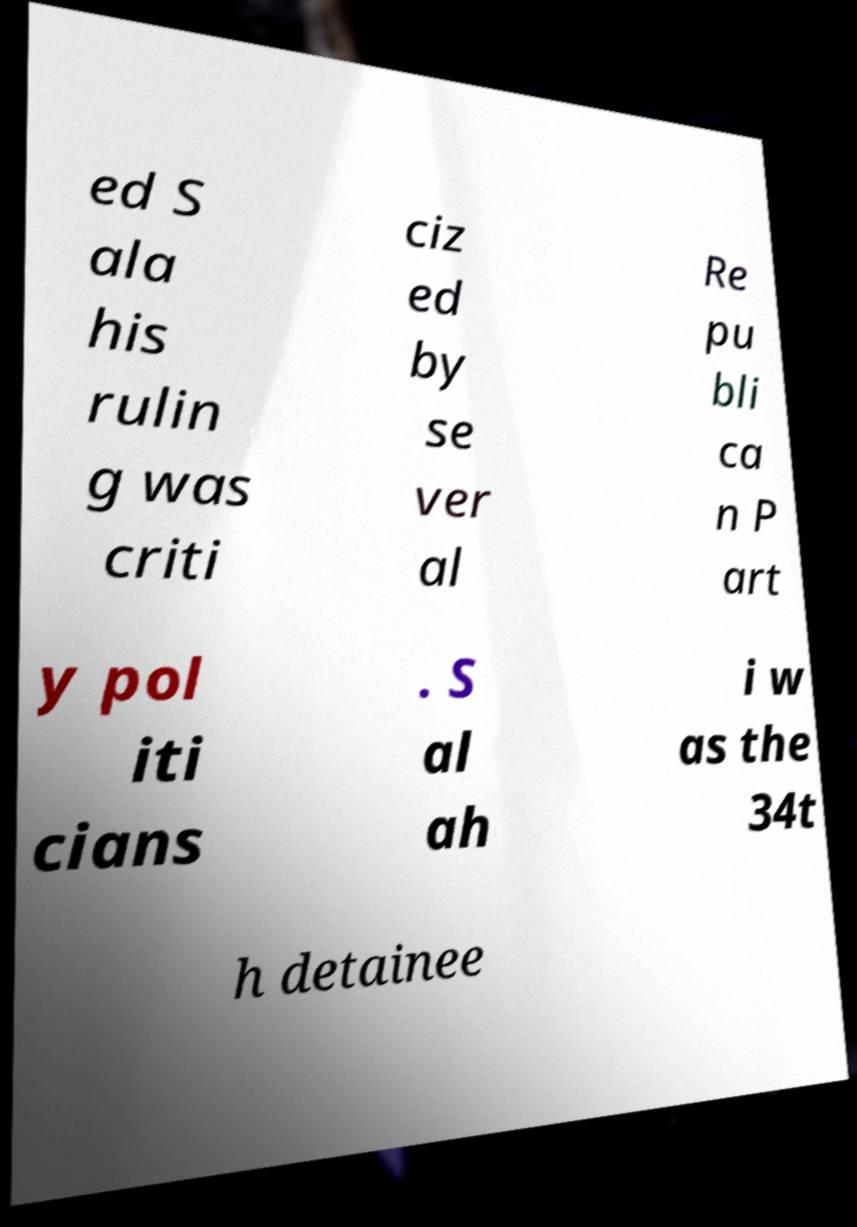Could you extract and type out the text from this image? ed S ala his rulin g was criti ciz ed by se ver al Re pu bli ca n P art y pol iti cians . S al ah i w as the 34t h detainee 